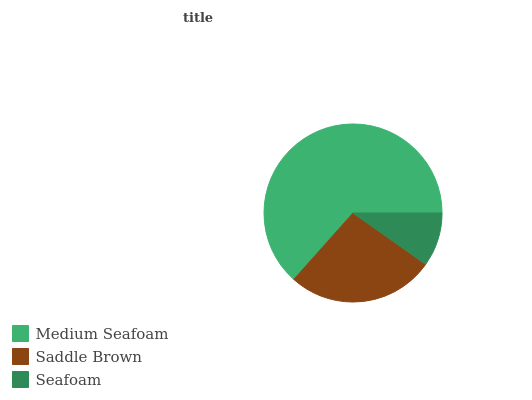Is Seafoam the minimum?
Answer yes or no. Yes. Is Medium Seafoam the maximum?
Answer yes or no. Yes. Is Saddle Brown the minimum?
Answer yes or no. No. Is Saddle Brown the maximum?
Answer yes or no. No. Is Medium Seafoam greater than Saddle Brown?
Answer yes or no. Yes. Is Saddle Brown less than Medium Seafoam?
Answer yes or no. Yes. Is Saddle Brown greater than Medium Seafoam?
Answer yes or no. No. Is Medium Seafoam less than Saddle Brown?
Answer yes or no. No. Is Saddle Brown the high median?
Answer yes or no. Yes. Is Saddle Brown the low median?
Answer yes or no. Yes. Is Seafoam the high median?
Answer yes or no. No. Is Seafoam the low median?
Answer yes or no. No. 